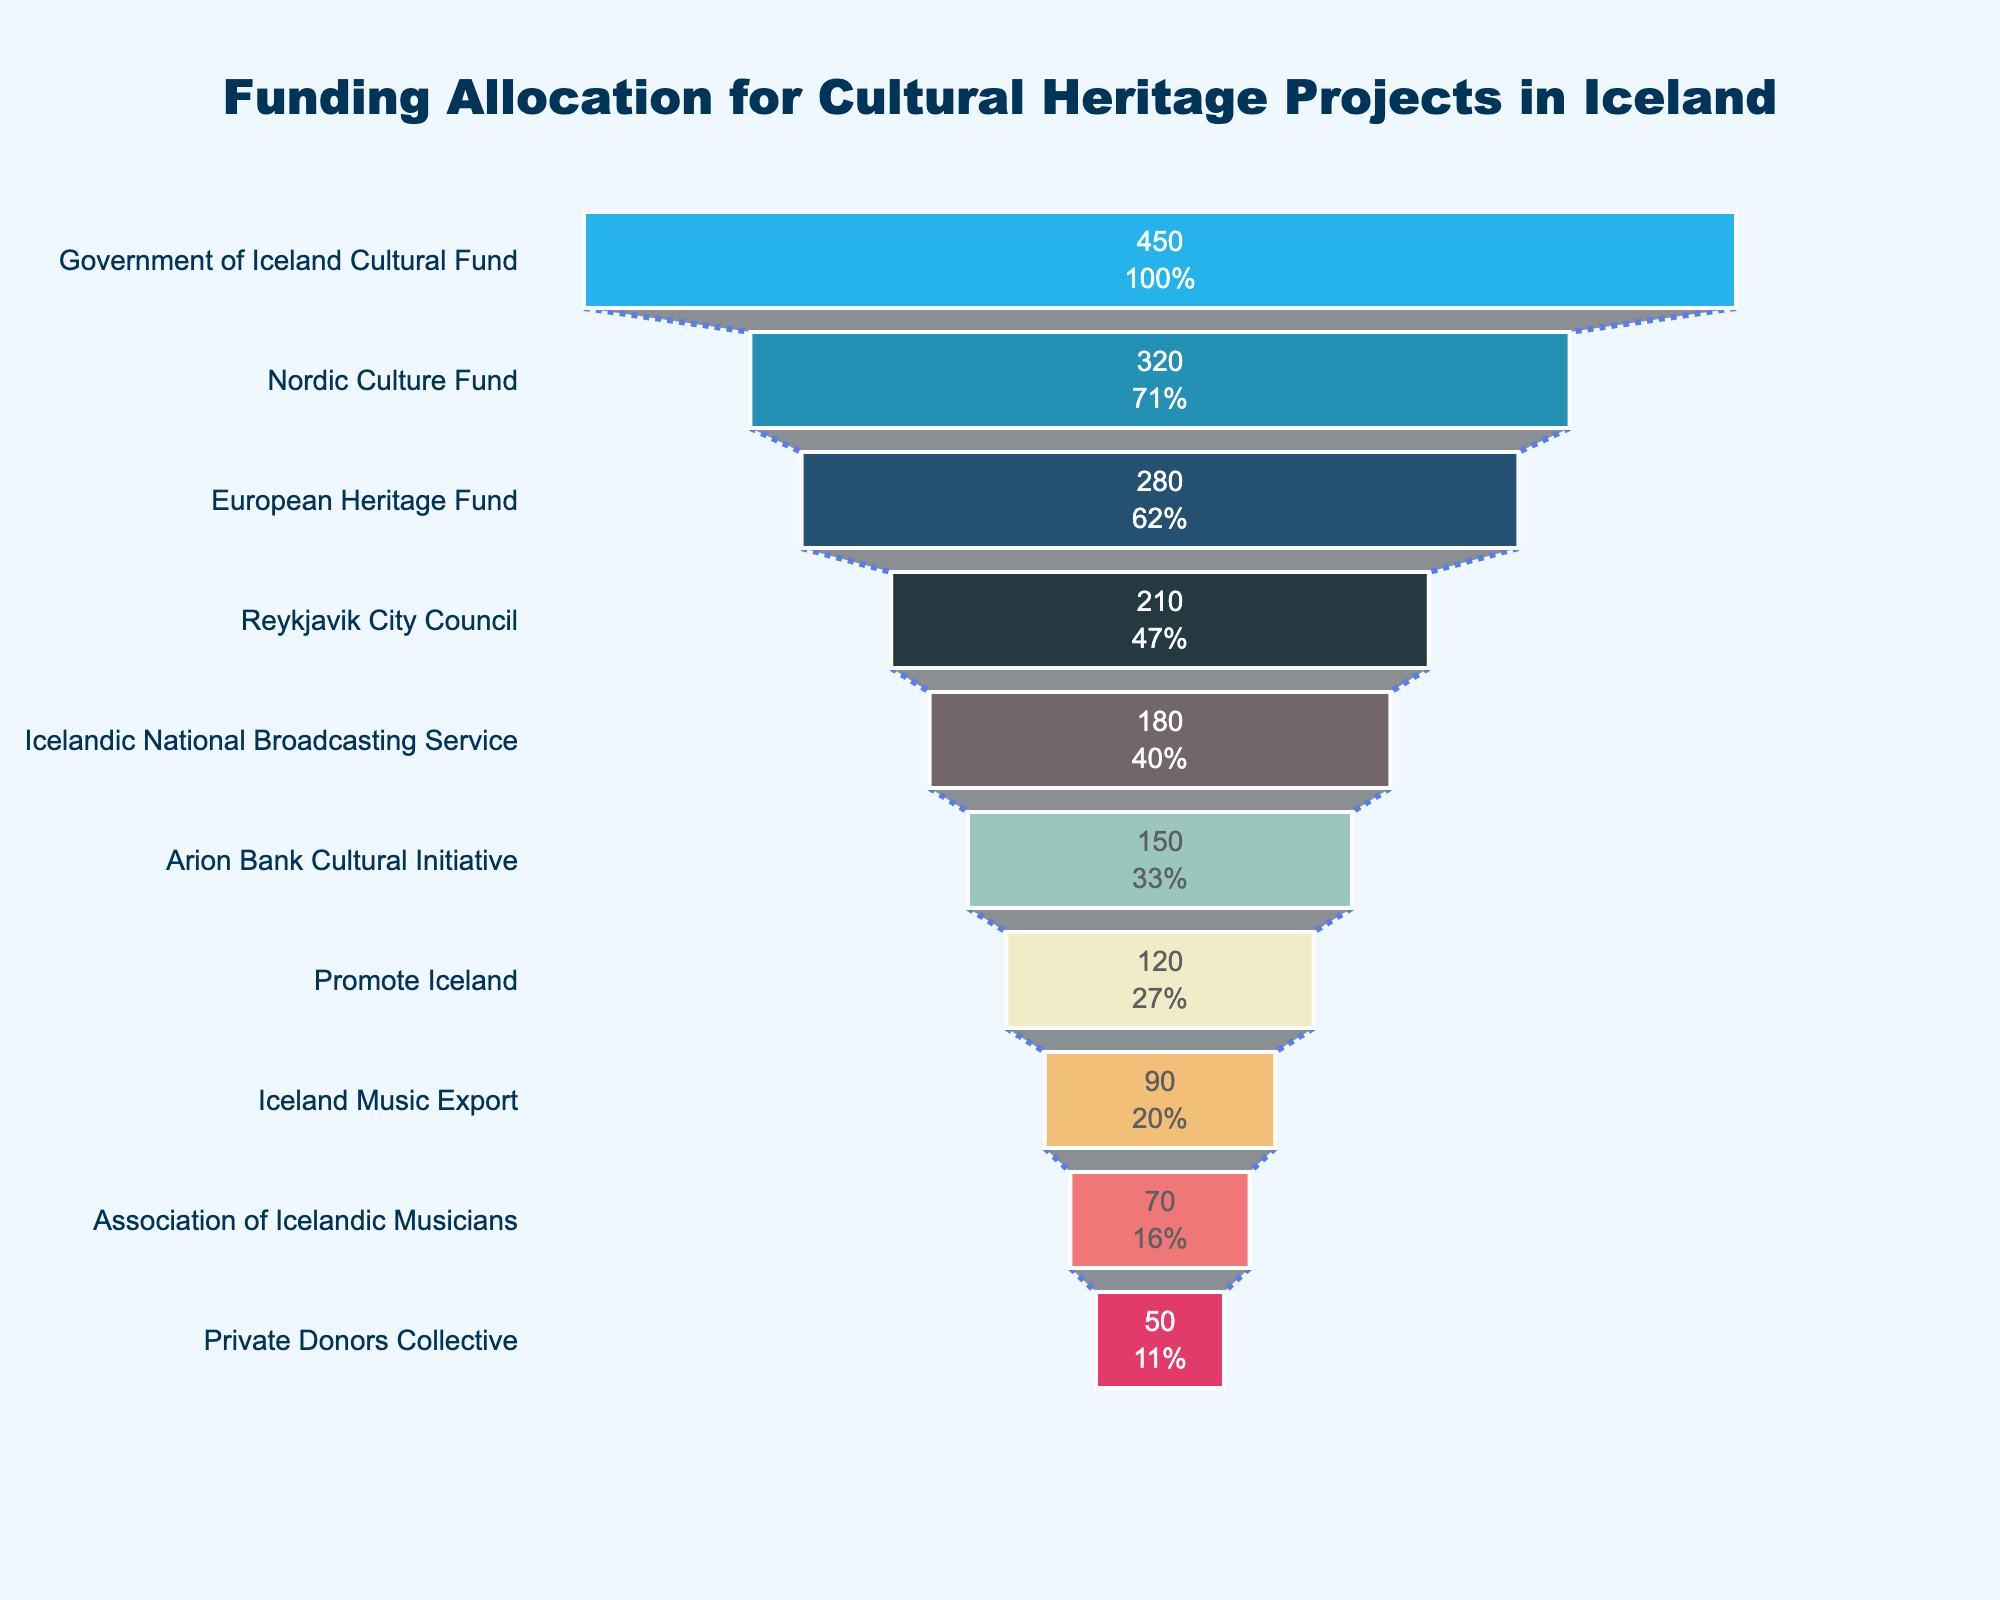How many funding sources are represented in the funnel chart? Count the number of unique entities listed along the funnel. Each bar represents a distinct funding source.
Answer: 10 Which funding source provides the highest amount of funding? Identify the top bar in the funnel chart, which corresponds to the highest funding amount. The bar at the top represents the largest contribution.
Answer: Government of Iceland Cultural Fund What is the total amount of funding provided by the top three sources? Sum the values of the first three bars in the funnel chart. These bars represent the top three funding sources. The respective amounts are 450, 320, and 280 ISK millions.
Answer: 1050 ISK millions Which funding source provides less than 100 ISK millions? Look for bars with funding values less than 100 ISK millions. In the funnel chart, these bars are relatively shorter.
Answer: Iceland Music Export, Association of Icelandic Musicians, Private Donors Collective By how much does the funding from the Government of Iceland Cultural Fund exceed the Reykjavik City Council? Subtract the amount provided by the Reykjavik City Council from the amount provided by the Government of Iceland Cultural Fund. The respective values are 450 and 210 ISK millions.
Answer: 240 ISK millions What percentage of the initial funding does the Iceland Music Export contribute? Locate the funding value associated with Iceland Music Export and find its percentage representation from the initial total. The initial total is represented by the Government of Iceland Cultural Fund (450 ISK millions). Calculate (90/450) * 100%.
Answer: 20% Which funding sources are represented by shades of blue in the chart? Identify the bars color-coded in any shade of blue. These bars correspond to different funding sources in the funnel chart.
Answer: Government of Iceland Cultural Fund, Nordic Culture Fund, European Heritage Fund, Reykjavik City Council What is the cumulative funding amount provided by non-governmental sources? Sum the funding amounts from all sources except the Government of Iceland Cultural Fund. Exclude the governmental source and add the others: 320 + 280 + 210 + 180 + 150 + 120 + 90 + 70 + 50 ISK millions.
Answer: 1470 ISK millions Which funding source contributes the least? Identify the bar at the bottom of the funnel chart, which represents the smallest contribution. This bar corresponds to the funding source with the lowest amount.
Answer: Private Donors Collective 